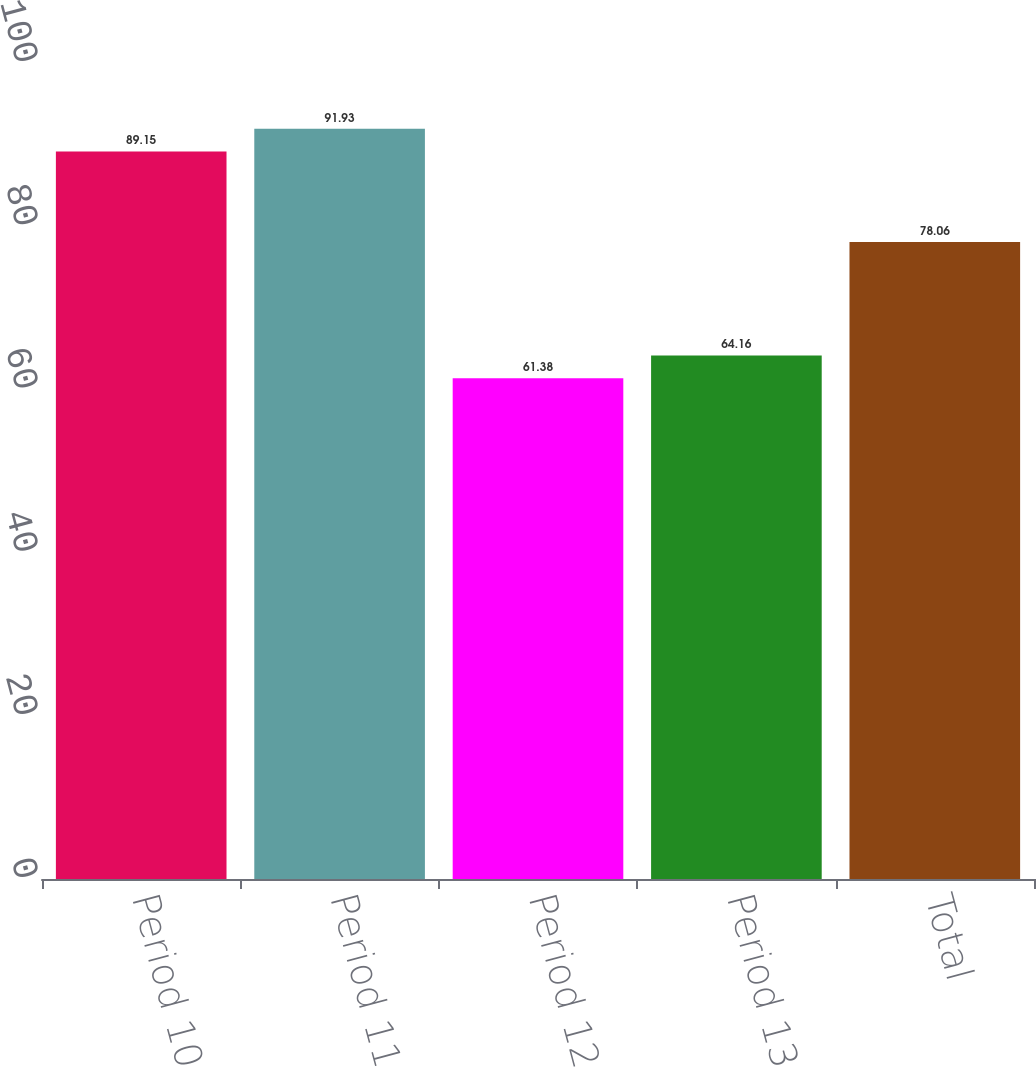Convert chart. <chart><loc_0><loc_0><loc_500><loc_500><bar_chart><fcel>Period 10<fcel>Period 11<fcel>Period 12<fcel>Period 13<fcel>Total<nl><fcel>89.15<fcel>91.93<fcel>61.38<fcel>64.16<fcel>78.06<nl></chart> 